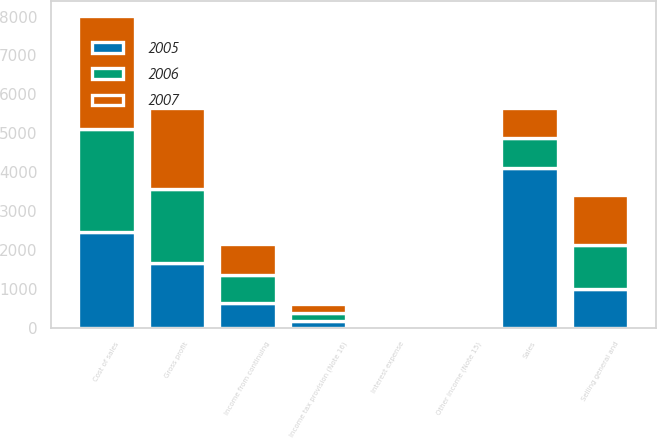<chart> <loc_0><loc_0><loc_500><loc_500><stacked_bar_chart><ecel><fcel>Sales<fcel>Cost of sales<fcel>Gross profit<fcel>Selling general and<fcel>Other income (Note 15)<fcel>Interest expense<fcel>Income from continuing<fcel>Income tax provision (Note 16)<nl><fcel>2007<fcel>762.2<fcel>2906.6<fcel>2097.3<fcel>1278.6<fcel>33.3<fcel>63.4<fcel>788.6<fcel>219.3<nl><fcel>2006<fcel>762.2<fcel>2656.4<fcel>1900<fcel>1141<fcel>33.4<fcel>56.6<fcel>735.8<fcel>206.5<nl><fcel>2005<fcel>4111.5<fcel>2448<fcel>1663.5<fcel>997.4<fcel>9.6<fcel>45.8<fcel>629.9<fcel>182.2<nl></chart> 